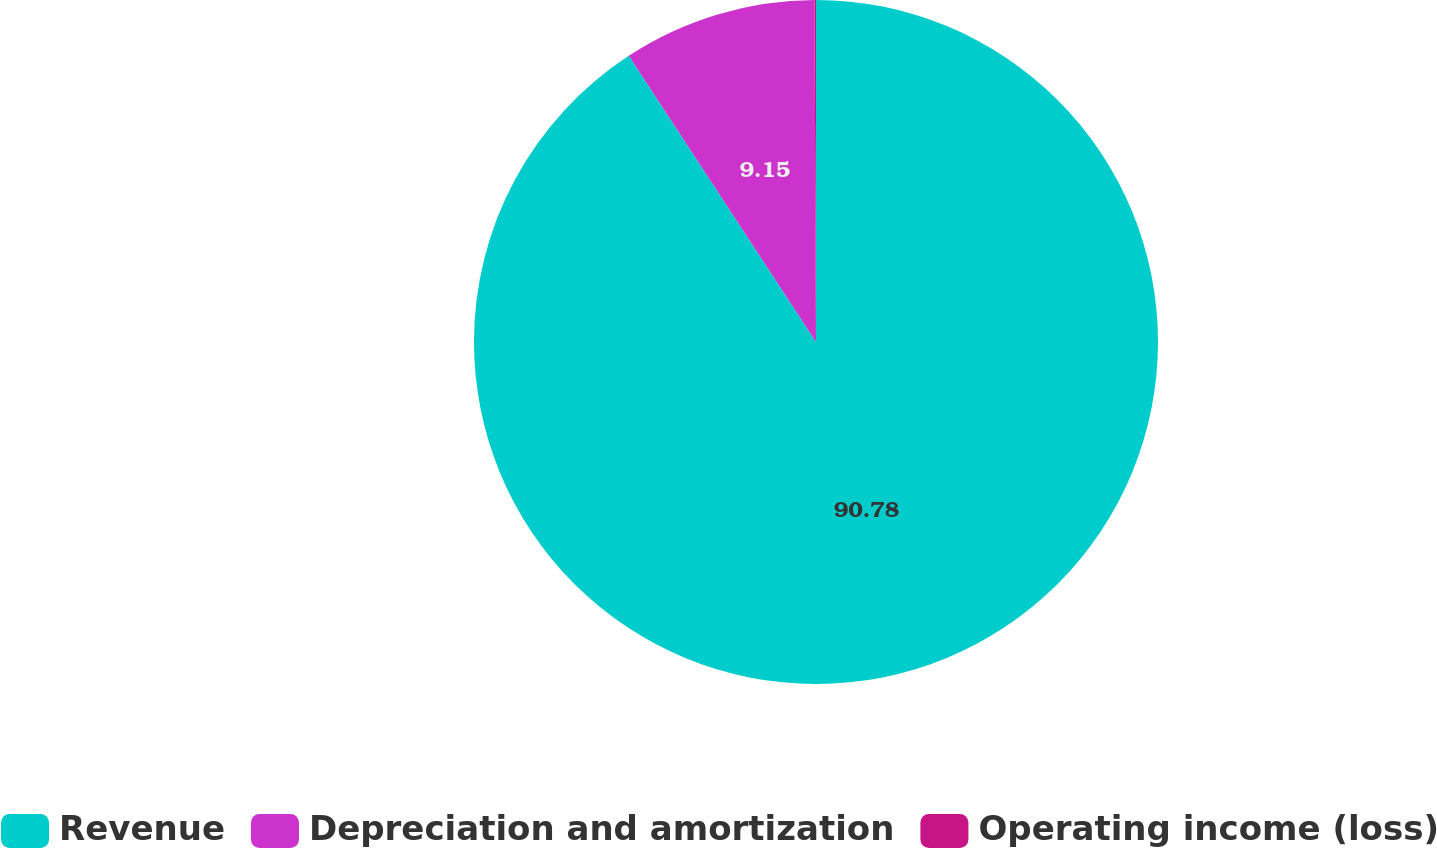<chart> <loc_0><loc_0><loc_500><loc_500><pie_chart><fcel>Revenue<fcel>Depreciation and amortization<fcel>Operating income (loss)<nl><fcel>90.78%<fcel>9.15%<fcel>0.07%<nl></chart> 